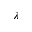Convert formula to latex. <formula><loc_0><loc_0><loc_500><loc_500>\lambda</formula> 